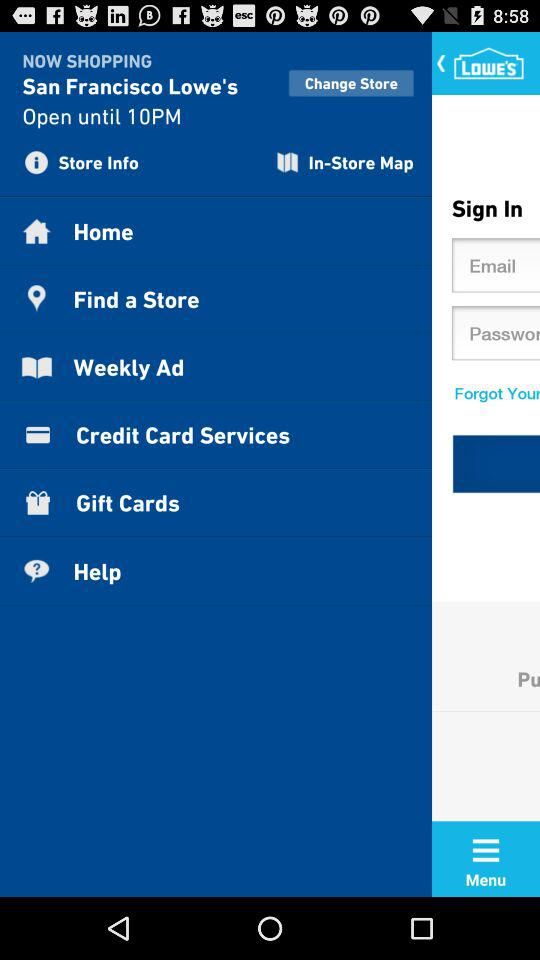What is the location?
When the provided information is insufficient, respond with <no answer>. <no answer> 